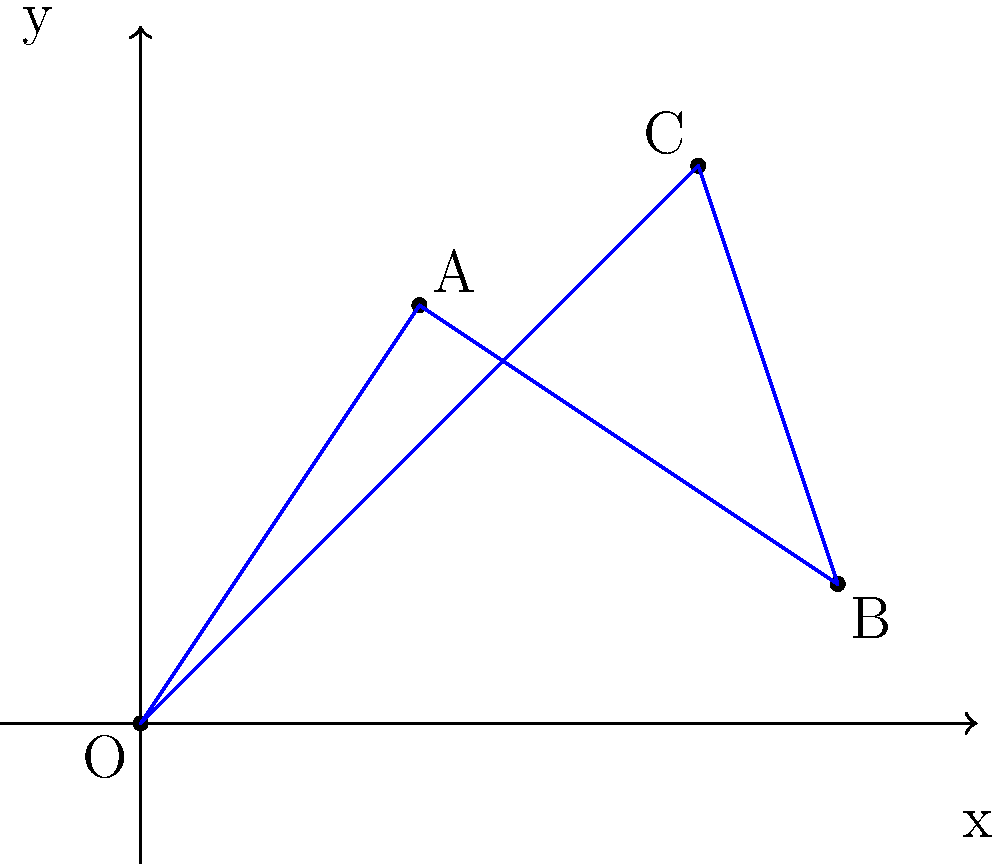In comic book backgrounds, perspective is crucial for creating depth. Given the coordinate system above, which point would you choose as the vanishing point to create a one-point perspective for a cityscape background, and why? To create a one-point perspective for a cityscape background, we need to consider the following steps:

1. Understand one-point perspective: In this technique, all parallel lines converge to a single vanishing point on the horizon line.

2. Analyze the given points:
   - Point O (0,0): Origin, typically used as a reference point
   - Point A (2,3): Above and to the right of the origin
   - Point B (5,1): Far to the right, close to the x-axis
   - Point C (4,4): Highest point, towards the upper right

3. Consider the cityscape requirements:
   - The vanishing point should be on or near the horizon line
   - It should be positioned to create a sense of depth and distance

4. Evaluate each point:
   - Point O is too low and would create an extreme perspective
   - Point A is too high for a typical horizon line
   - Point C is the highest and would create an unrealistic perspective
   - Point B is closest to a typical horizon line position

5. Choose the best point: Point B (5,1) is the most suitable choice because:
   - It's positioned near the x-axis, which can serve as the horizon line
   - Its position on the right side of the frame allows for a dynamic composition
   - The slight elevation above the x-axis can create an interesting viewpoint, as if the viewer is looking slightly upward at the cityscape

6. Application in comic book design:
   - Use Point B as the vanishing point for all receding parallel lines
   - Draw buildings and streets converging towards this point
   - This will create a sense of depth and draw the reader's eye into the scene
Answer: Point B (5,1) 